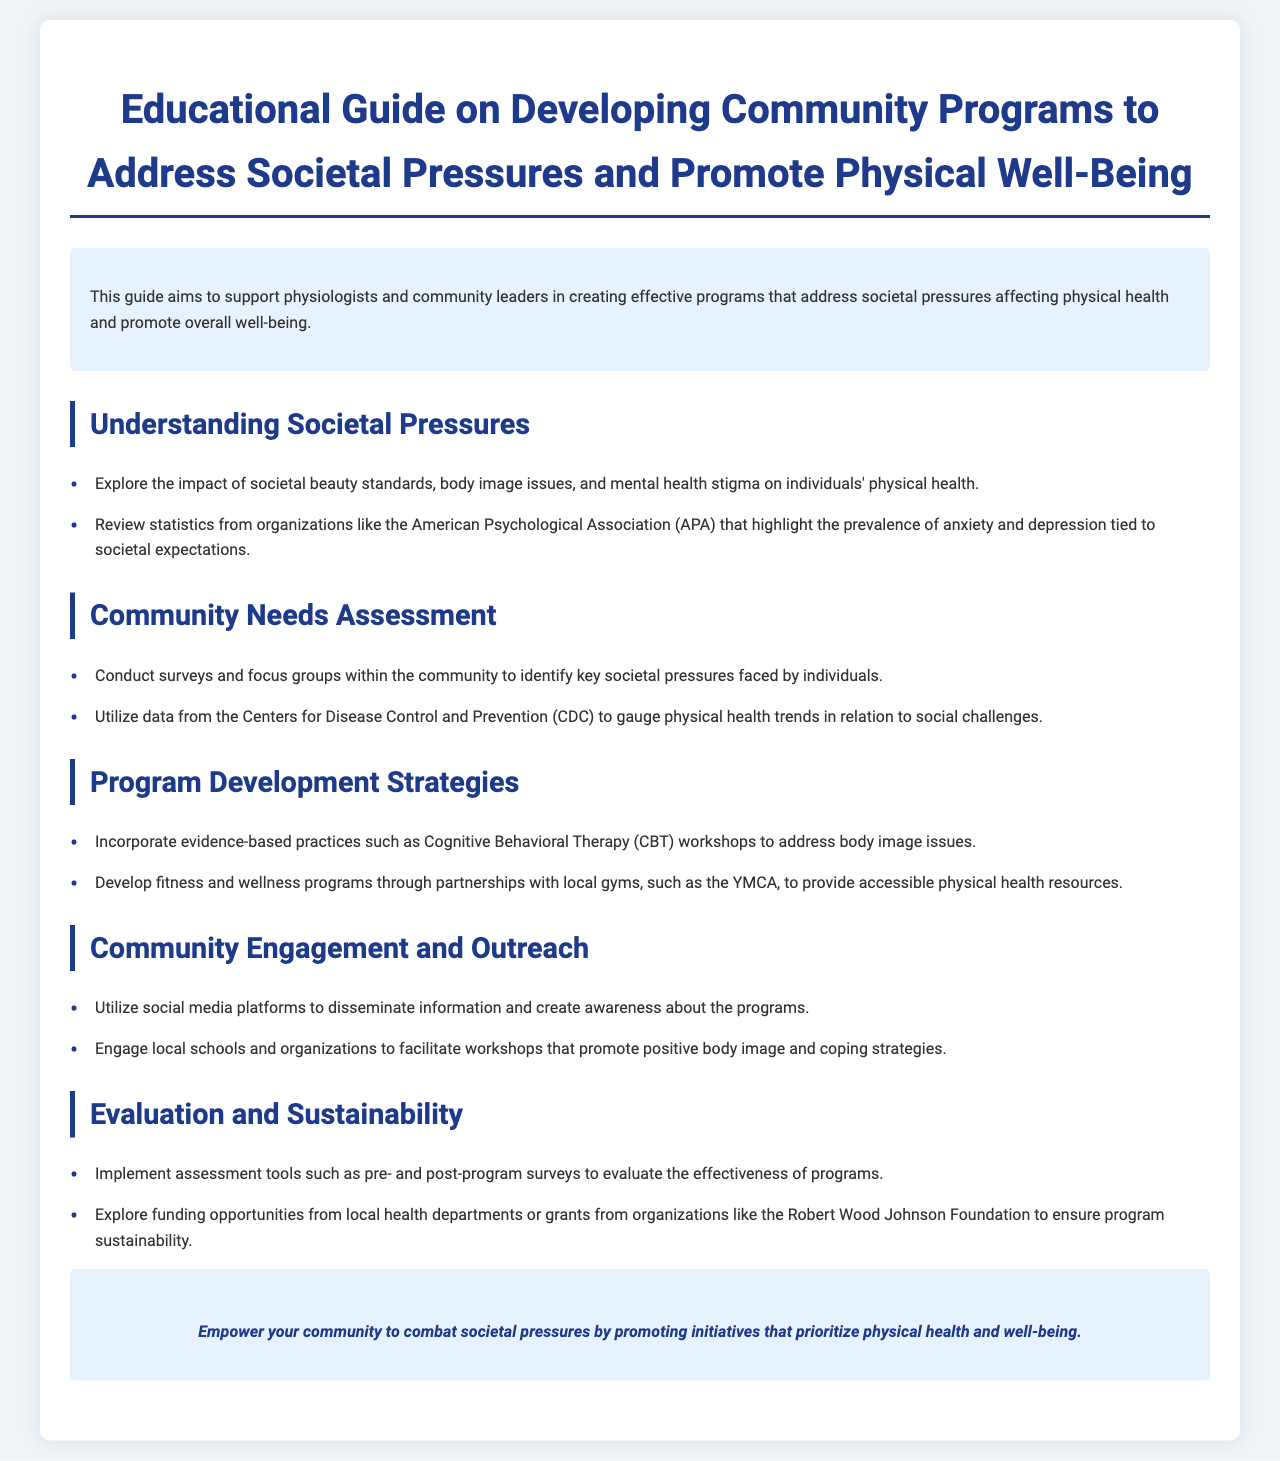What is the title of the guide? The title of the guide is presented in the header of the document.
Answer: Educational Guide on Developing Community Programs to Address Societal Pressures and Promote Physical Well-Being What organization’s statistics are mentioned for anxiety and depression? The document specifies the organization that provides statistics on mental health related to societal expectations.
Answer: American Psychological Association (APA) What strategy is suggested for addressing body image issues? The document mentions a specific evidence-based practice for this issue.
Answer: Cognitive Behavioral Therapy (CBT) workshops Which type of outreach is recommended to promote community programs? The document discusses a specific method for raising awareness about programs.
Answer: Social media platforms What is one of the funding sources for program sustainability mentioned? The guide provides examples of potential funding sources for sustainable programs.
Answer: Robert Wood Johnson Foundation What is the purpose of conducting surveys and focus groups? The guide outlines the goal of these assessments within the community context.
Answer: Identify key societal pressures faced by individuals What are two components included in the evaluation of programs? The document outlines essential elements necessary for program assessment.
Answer: Pre- and post-program surveys What is highlighted as a key component for community engagement? The guide emphasizes a specific action to involve the local community in initiatives.
Answer: Engage local schools and organizations What key issue regarding health does the guide explore? The guide emphasizes the relationship between societal factors and a specific aspect of health.
Answer: Physical health 